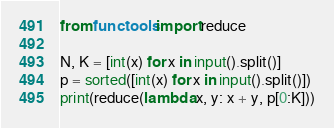Convert code to text. <code><loc_0><loc_0><loc_500><loc_500><_Python_>from functools import reduce

N, K = [int(x) for x in input().split()]
p = sorted([int(x) for x in input().split()])
print(reduce(lambda x, y: x + y, p[0:K]))</code> 